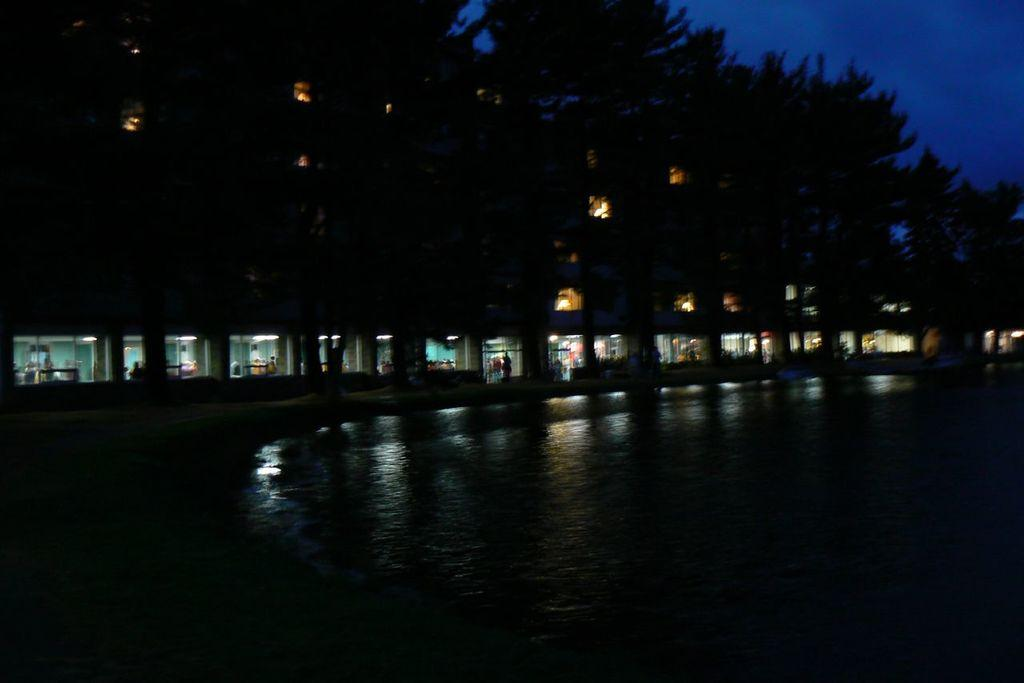What is the main subject in the center of the image? There is water in the center of the image. What can be seen in the background of the image? There are trees in the background of the image. What else is visible in the image besides the water and trees? There are lights visible in the image. What type of cabbage is growing near the water in the image? There is no cabbage present in the image; it only features water, trees, and lights. Can you see a bear near the water in the image? There is no bear present in the image; it only features water, trees, and lights. 